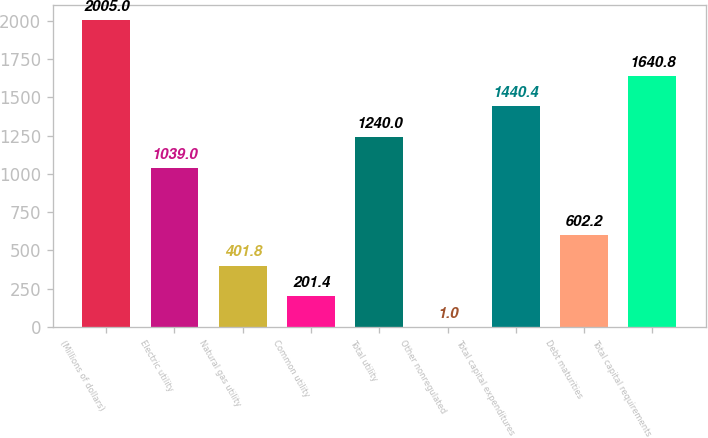Convert chart. <chart><loc_0><loc_0><loc_500><loc_500><bar_chart><fcel>(Millions of dollars)<fcel>Electric utility<fcel>Natural gas utility<fcel>Common utility<fcel>Total utility<fcel>Other nonregulated<fcel>Total capital expenditures<fcel>Debt maturities<fcel>Total capital requirements<nl><fcel>2005<fcel>1039<fcel>401.8<fcel>201.4<fcel>1240<fcel>1<fcel>1440.4<fcel>602.2<fcel>1640.8<nl></chart> 